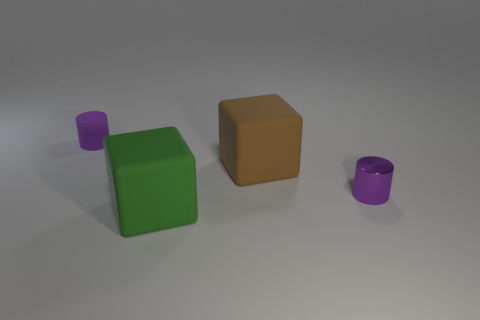Are there fewer small objects than large gray matte things?
Make the answer very short. No. The matte thing that is both in front of the tiny purple rubber thing and behind the small metallic thing is what color?
Ensure brevity in your answer.  Brown. What material is the other tiny purple object that is the same shape as the tiny matte thing?
Offer a very short reply. Metal. Is there anything else that has the same size as the metallic cylinder?
Provide a succinct answer. Yes. Are there more blue metal blocks than small purple rubber objects?
Provide a succinct answer. No. There is a object that is both behind the shiny cylinder and to the right of the big green rubber cube; what size is it?
Give a very brief answer. Large. What is the shape of the big brown matte object?
Offer a very short reply. Cube. What number of other purple rubber things are the same shape as the small matte thing?
Your answer should be very brief. 0. Is the number of small matte cylinders behind the small shiny cylinder less than the number of objects left of the brown rubber thing?
Your answer should be very brief. Yes. There is a purple thing behind the brown matte thing; what number of tiny purple rubber objects are behind it?
Ensure brevity in your answer.  0. 